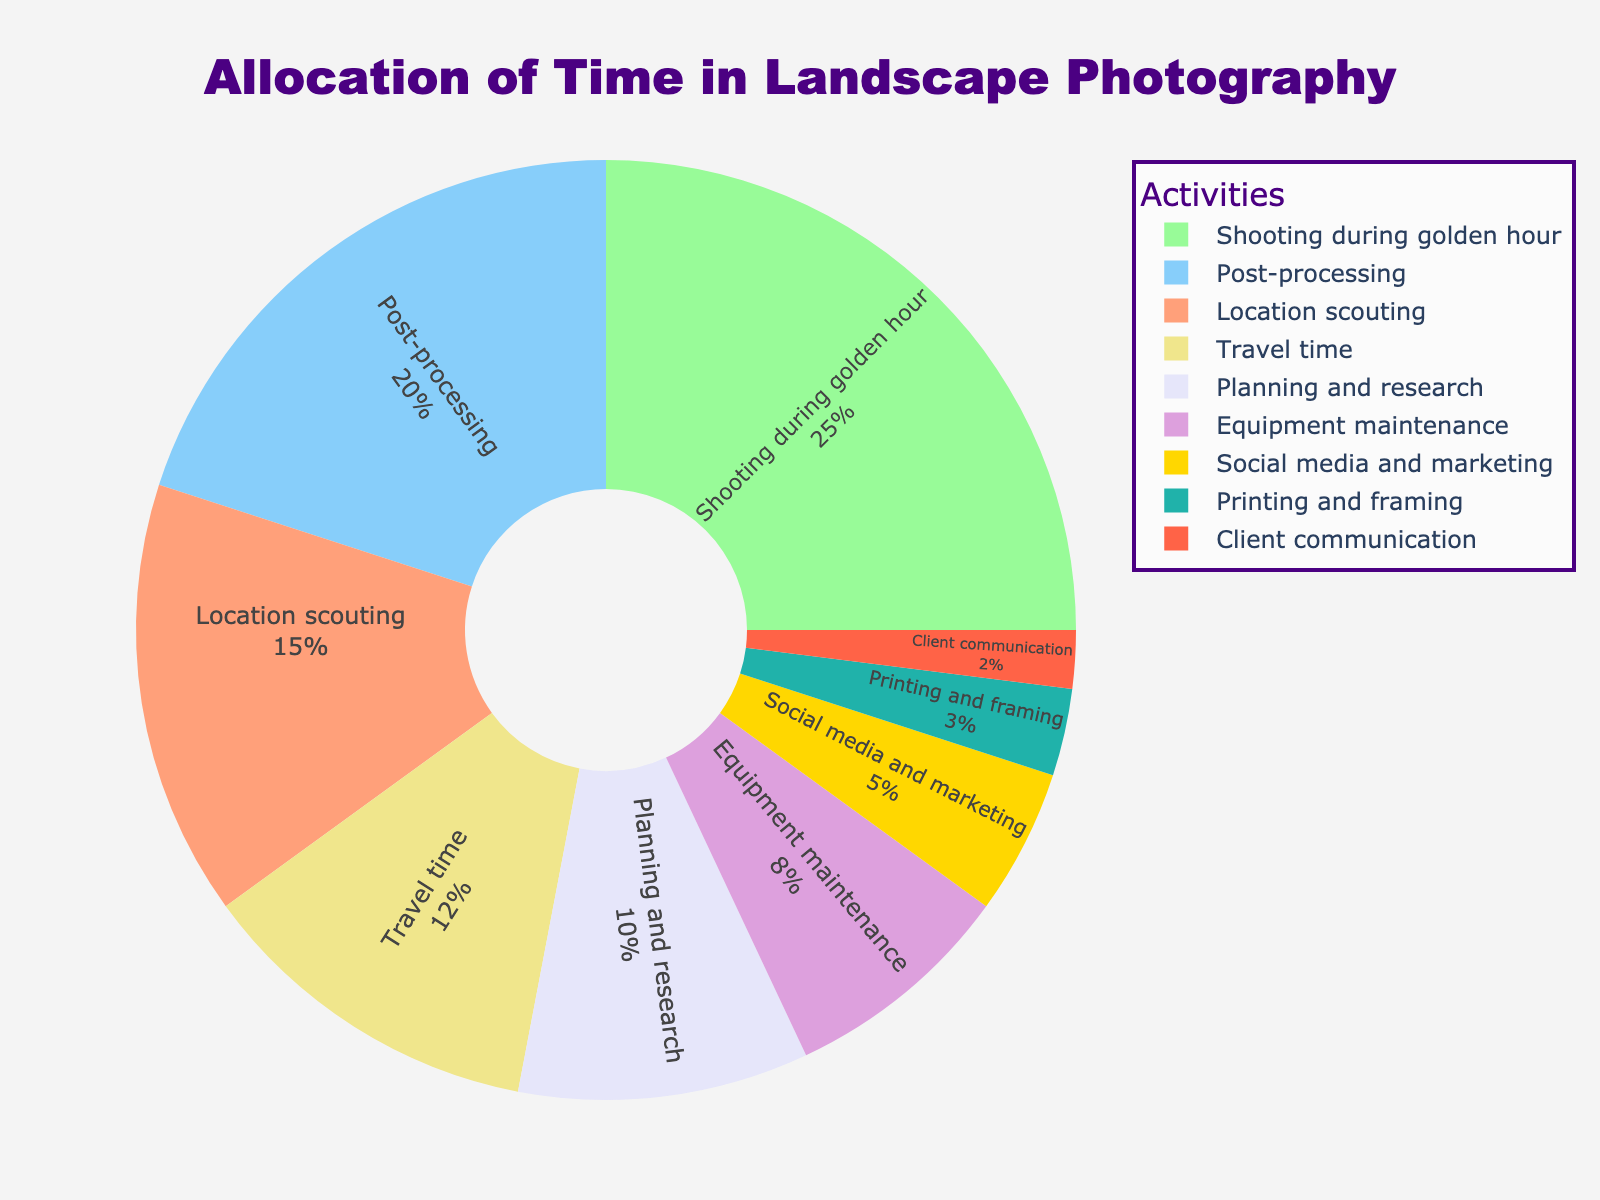What activity takes up the most time in your landscape photography workflow? The figure shows that "Shooting during golden hour" has the highest percentage with 25%.
Answer: Shooting during golden hour Which two activities combined take up more time than post-processing? "Location scouting" (15%) and "Travel time" (12%) together account for 27%, which is more than "Post-processing" at 20%.
Answer: Location scouting and Travel time How much time is allocated to planning, research, and client communication in total? "Planning and research" is 10% and "Client communication" is 2%, so their total is 10% + 2% = 12%.
Answer: 12% Which activity takes less time: Equipment maintenance or Social media and marketing? Social media and marketing is 5%, which is less than equipment maintenance at 8%.
Answer: Social media and marketing What is the difference in time allocation between Travel time and Printing and framing? "Travel time" is 12% and "Printing and framing" is 3%, so the difference is 12% - 3% = 9%.
Answer: 9% Which two activities have the closest time allocation percentages? "Planning and research" (10%) and "Location scouting" (15%) are relatively close to each other when compared to other activities.
Answer: Planning and research and Location scouting What is the combined percentage for equipment maintenance, printing and framing, and client communication? Adding up the percentages: Equipment maintenance (8%), Printing and framing (3%), and Client communication (2%), we get 8% + 3% + 2% = 13%.
Answer: 13% Is the percentage allocated for shooting during golden hour higher than the combined percentage for social media and marketing plus client communication? "Shooting during golden hour" is 25%, while "Social media and marketing" is 5% and "Client communication" is 2%, which together are 5% + 2% = 7%. Since 25% > 7%, the answer is yes.
Answer: Yes How does the time spent on post-processing compare to the time spent on planning and research plus client communication? "Post-processing" is 20%, while "Planning and research" and "Client communication" combined are 10% + 2% = 12%. Thus, post-processing takes more time.
Answer: Post-processing takes more time 